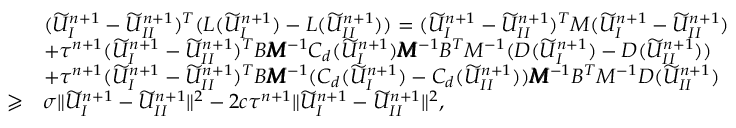Convert formula to latex. <formula><loc_0><loc_0><loc_500><loc_500>\begin{array} { r l } & { ( \widetilde { U } _ { I } ^ { n + 1 } - \widetilde { U } _ { I I } ^ { n + 1 } ) ^ { T } ( L ( \widetilde { U } _ { I } ^ { n + 1 } ) - L ( \widetilde { U } _ { I I } ^ { n + 1 } ) ) = ( \widetilde { U } _ { I } ^ { n + 1 } - \widetilde { U } _ { I I } ^ { n + 1 } ) ^ { T } M ( \widetilde { U } _ { I } ^ { n + 1 } - \widetilde { U } _ { I I } ^ { n + 1 } ) } \\ & { + \tau ^ { n + 1 } ( \widetilde { U } _ { I } ^ { n + 1 } - \widetilde { U } _ { I I } ^ { n + 1 } ) ^ { T } B \pm b { M } ^ { - 1 } C _ { d } ( \widetilde { U } _ { I } ^ { n + 1 } ) \pm b { M } ^ { - 1 } B ^ { T } M ^ { - 1 } ( D ( \widetilde { U } _ { I } ^ { n + 1 } ) - D ( \widetilde { U } _ { I I } ^ { n + 1 } ) ) } \\ & { + \tau ^ { n + 1 } ( \widetilde { U } _ { I } ^ { n + 1 } - \widetilde { U } _ { I I } ^ { n + 1 } ) ^ { T } B \pm b { M } ^ { - 1 } ( C _ { d } ( \widetilde { U } _ { I } ^ { n + 1 } ) - C _ { d } ( \widetilde { U } _ { I I } ^ { n + 1 } ) ) \pm b { M } ^ { - 1 } B ^ { T } M ^ { - 1 } D ( \widetilde { U } _ { I I } ^ { n + 1 } ) } \\ { \geqslant } & { \sigma \| \widetilde { U } _ { I } ^ { n + 1 } - \widetilde { U } _ { I I } ^ { n + 1 } \| ^ { 2 } - 2 c \tau ^ { n + 1 } \| \widetilde { U } _ { I } ^ { n + 1 } - \widetilde { U } _ { I I } ^ { n + 1 } \| ^ { 2 } , } \end{array}</formula> 